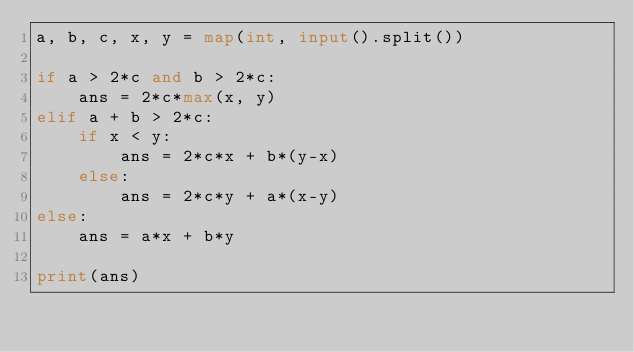Convert code to text. <code><loc_0><loc_0><loc_500><loc_500><_Python_>a, b, c, x, y = map(int, input().split())

if a > 2*c and b > 2*c:
    ans = 2*c*max(x, y)  
elif a + b > 2*c:
    if x < y:
        ans = 2*c*x + b*(y-x)
    else:
        ans = 2*c*y + a*(x-y)
else:
    ans = a*x + b*y

print(ans)
</code> 